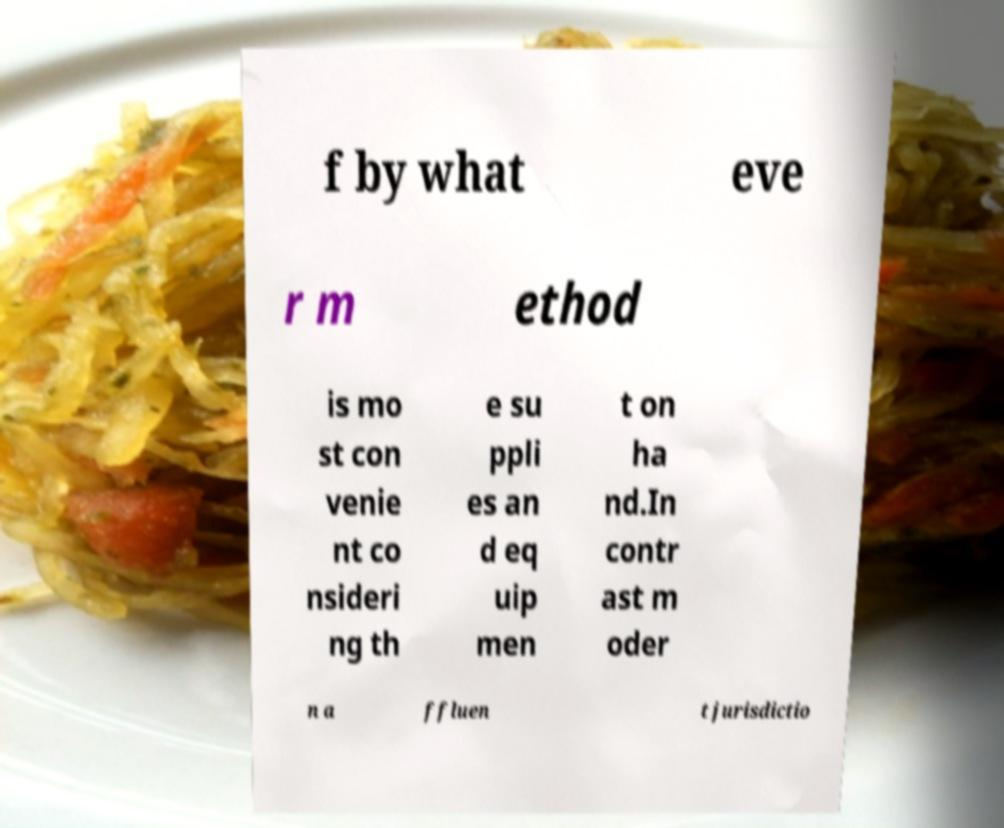There's text embedded in this image that I need extracted. Can you transcribe it verbatim? f by what eve r m ethod is mo st con venie nt co nsideri ng th e su ppli es an d eq uip men t on ha nd.In contr ast m oder n a ffluen t jurisdictio 